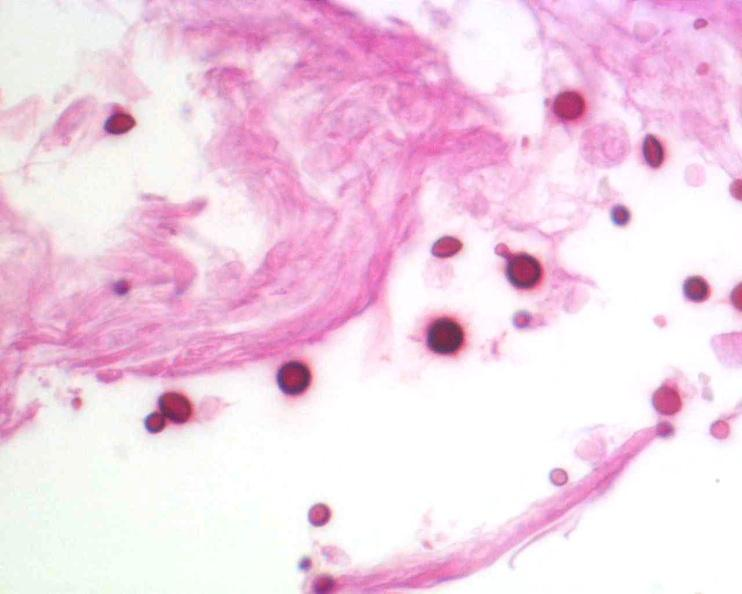what does this image show?
Answer the question using a single word or phrase. Brain 